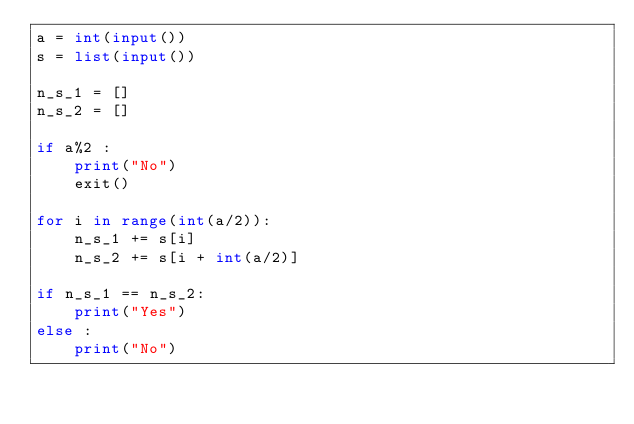Convert code to text. <code><loc_0><loc_0><loc_500><loc_500><_Python_>a = int(input())
s = list(input())

n_s_1 = []
n_s_2 = []

if a%2 :
    print("No")
    exit()

for i in range(int(a/2)):
    n_s_1 += s[i]
    n_s_2 += s[i + int(a/2)]

if n_s_1 == n_s_2:
    print("Yes")
else :
    print("No")</code> 